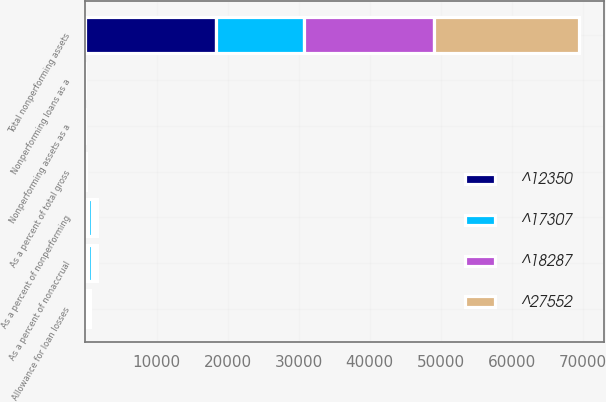Convert chart to OTSL. <chart><loc_0><loc_0><loc_500><loc_500><stacked_bar_chart><ecel><fcel>Total nonperforming assets<fcel>Nonperforming loans as a<fcel>Nonperforming assets as a<fcel>Allowance for loan losses<fcel>As a percent of total gross<fcel>As a percent of nonaccrual<fcel>As a percent of nonperforming<nl><fcel>^17307<fcel>12350<fcel>0.6<fcel>0.3<fcel>174.85<fcel>3.2<fcel>522.3<fcel>522.3<nl><fcel>^27552<fcel>20411<fcel>1<fcel>0.5<fcel>174.85<fcel>3.4<fcel>345.4<fcel>345.4<nl><fcel>^18287<fcel>18307<fcel>1<fcel>0.4<fcel>174.85<fcel>4.1<fcel>418.2<fcel>395.3<nl><fcel>^12350<fcel>18385<fcel>1.1<fcel>0.3<fcel>174.85<fcel>4.3<fcel>403.6<fcel>401.4<nl></chart> 